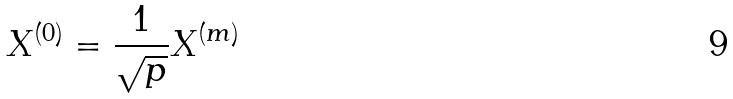<formula> <loc_0><loc_0><loc_500><loc_500>X ^ { ( 0 ) } = \frac { 1 } { \sqrt { p } } X ^ { ( m ) }</formula> 